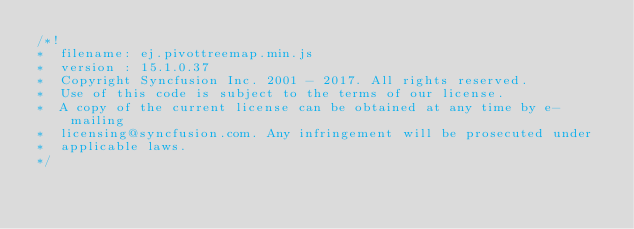Convert code to text. <code><loc_0><loc_0><loc_500><loc_500><_JavaScript_>/*!
*  filename: ej.pivottreemap.min.js
*  version : 15.1.0.37
*  Copyright Syncfusion Inc. 2001 - 2017. All rights reserved.
*  Use of this code is subject to the terms of our license.
*  A copy of the current license can be obtained at any time by e-mailing
*  licensing@syncfusion.com. Any infringement will be prosecuted under
*  applicable laws. 
*/</code> 